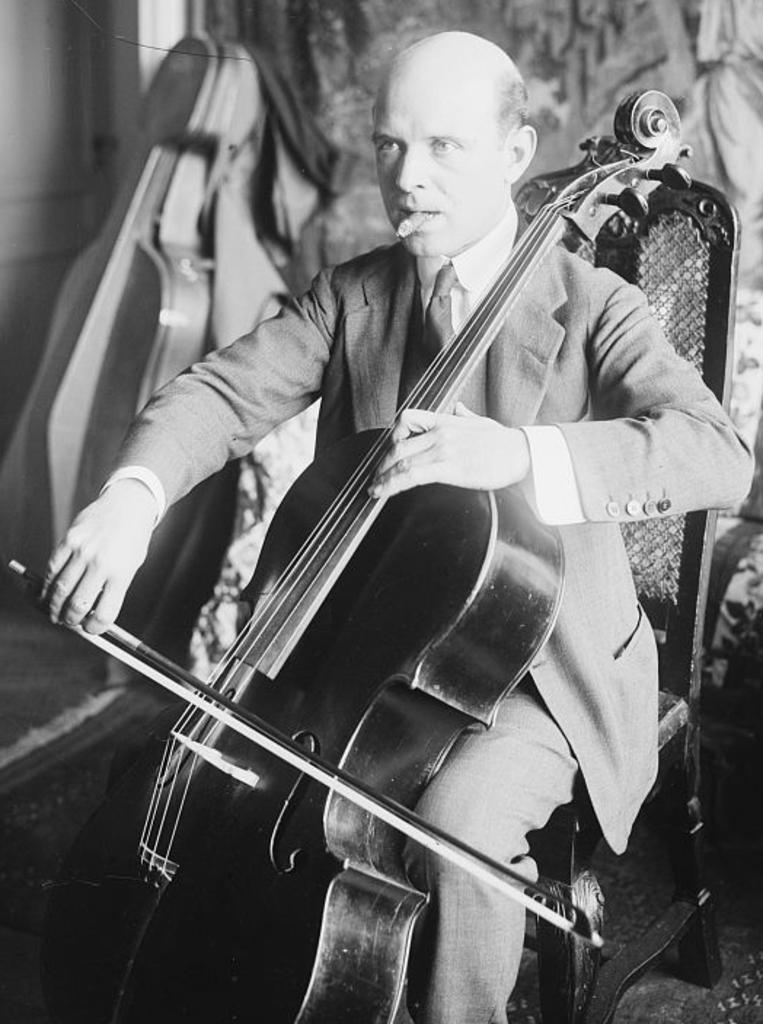What is the color scheme of the image? The image is black and white. What is the person in the image doing? The person is playing a guitar. Can you describe the person's activity in more detail? The person is sitting while playing the guitar. How many cakes are on the table next to the person in the image? There is no table or cakes present in the image; it only features a person playing a guitar in a black and white setting. 